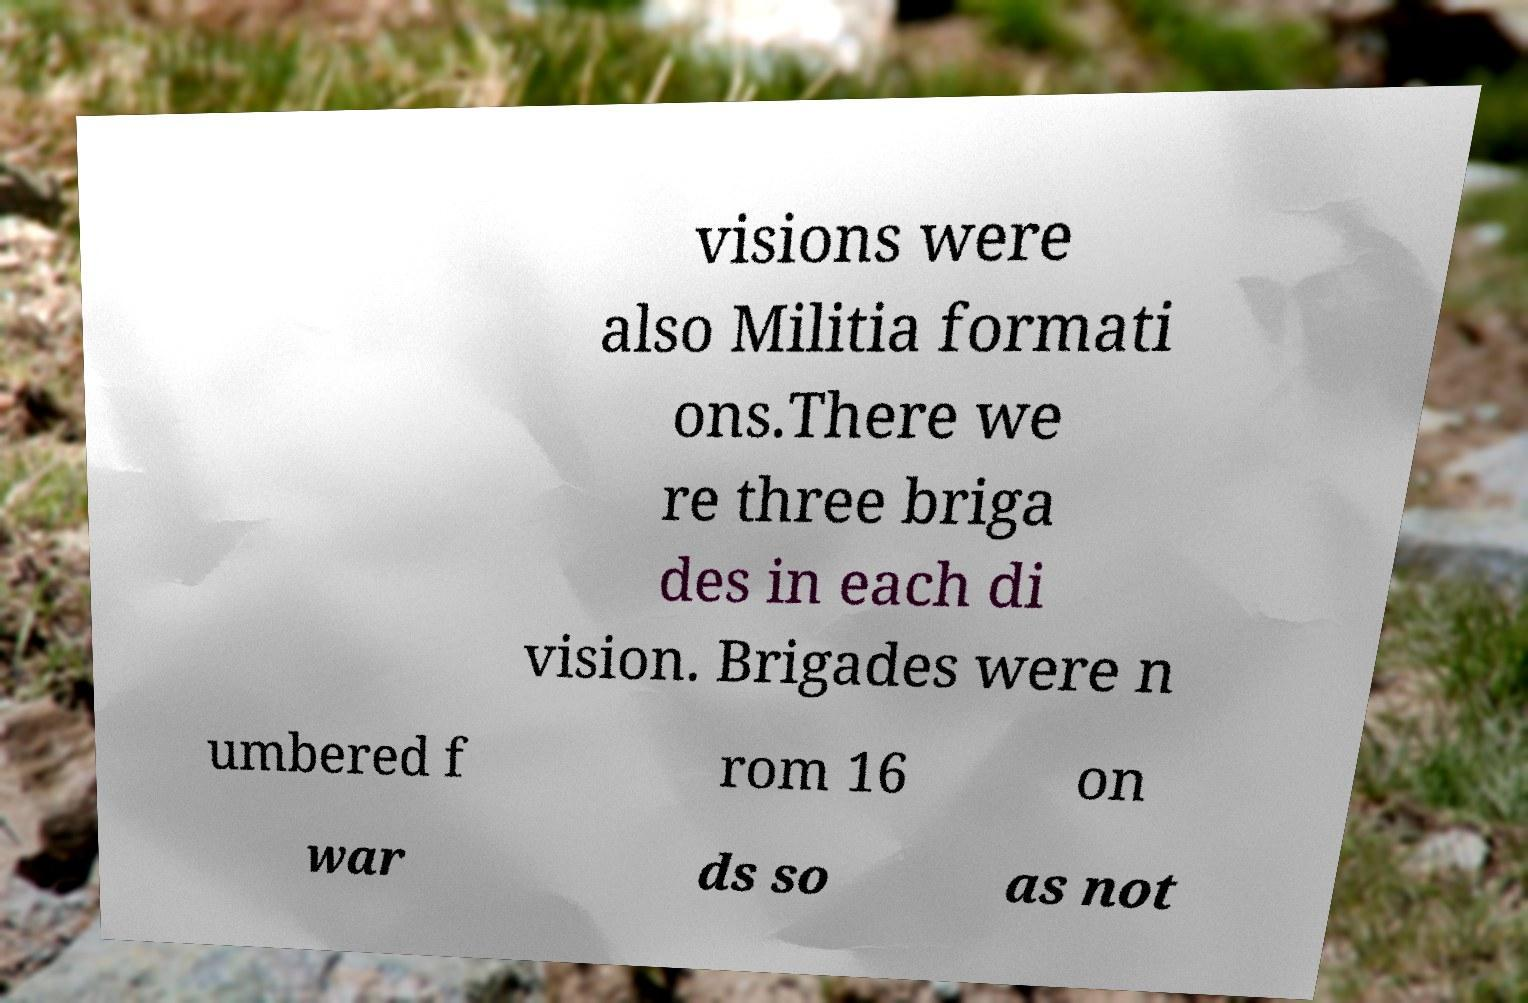Could you extract and type out the text from this image? visions were also Militia formati ons.There we re three briga des in each di vision. Brigades were n umbered f rom 16 on war ds so as not 